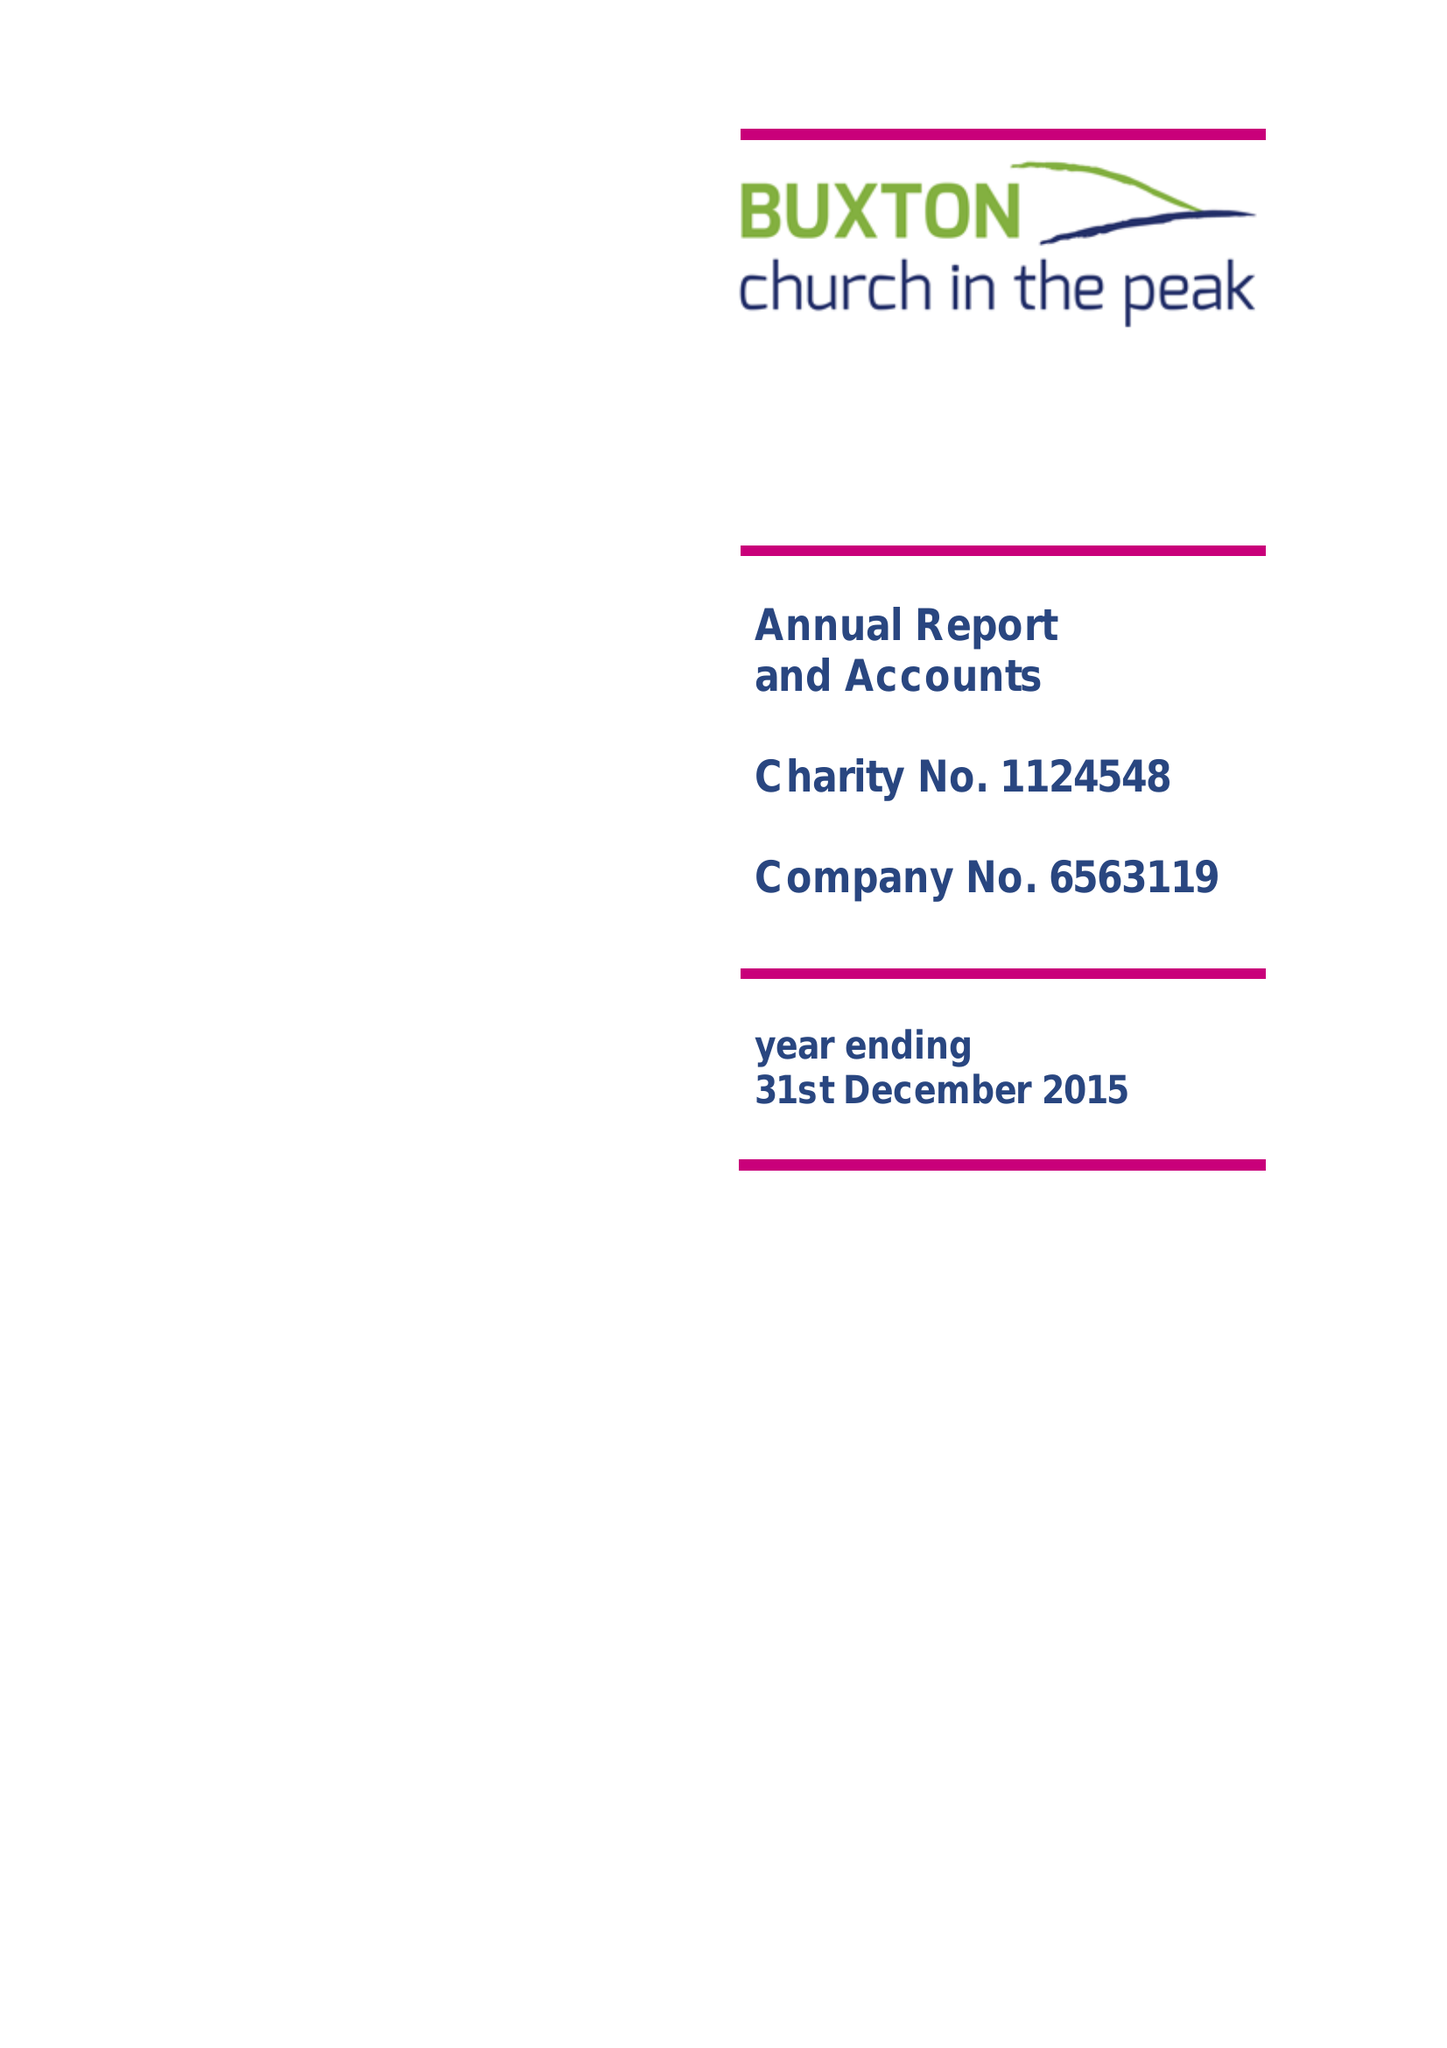What is the value for the report_date?
Answer the question using a single word or phrase. 2015-12-31 